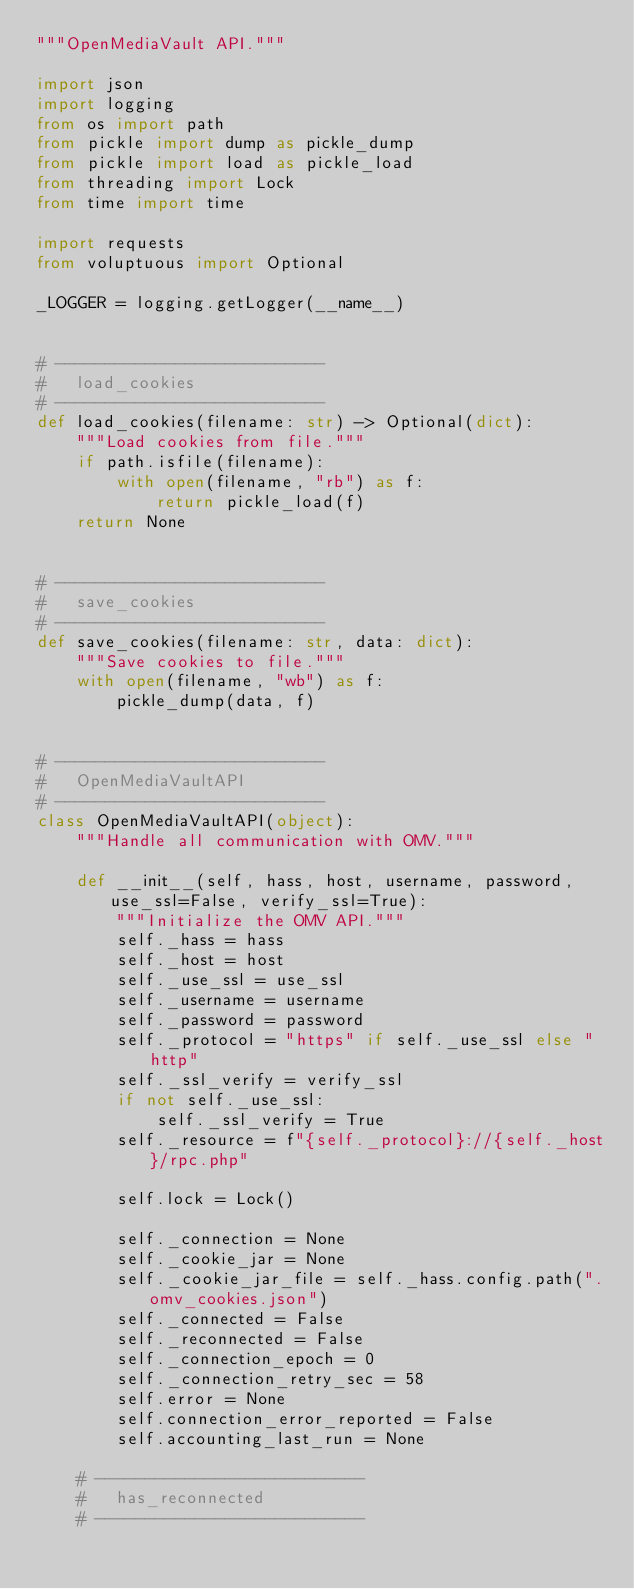<code> <loc_0><loc_0><loc_500><loc_500><_Python_>"""OpenMediaVault API."""

import json
import logging
from os import path
from pickle import dump as pickle_dump
from pickle import load as pickle_load
from threading import Lock
from time import time

import requests
from voluptuous import Optional

_LOGGER = logging.getLogger(__name__)


# ---------------------------
#   load_cookies
# ---------------------------
def load_cookies(filename: str) -> Optional(dict):
    """Load cookies from file."""
    if path.isfile(filename):
        with open(filename, "rb") as f:
            return pickle_load(f)
    return None


# ---------------------------
#   save_cookies
# ---------------------------
def save_cookies(filename: str, data: dict):
    """Save cookies to file."""
    with open(filename, "wb") as f:
        pickle_dump(data, f)


# ---------------------------
#   OpenMediaVaultAPI
# ---------------------------
class OpenMediaVaultAPI(object):
    """Handle all communication with OMV."""

    def __init__(self, hass, host, username, password, use_ssl=False, verify_ssl=True):
        """Initialize the OMV API."""
        self._hass = hass
        self._host = host
        self._use_ssl = use_ssl
        self._username = username
        self._password = password
        self._protocol = "https" if self._use_ssl else "http"
        self._ssl_verify = verify_ssl
        if not self._use_ssl:
            self._ssl_verify = True
        self._resource = f"{self._protocol}://{self._host}/rpc.php"

        self.lock = Lock()

        self._connection = None
        self._cookie_jar = None
        self._cookie_jar_file = self._hass.config.path(".omv_cookies.json")
        self._connected = False
        self._reconnected = False
        self._connection_epoch = 0
        self._connection_retry_sec = 58
        self.error = None
        self.connection_error_reported = False
        self.accounting_last_run = None

    # ---------------------------
    #   has_reconnected
    # ---------------------------</code> 